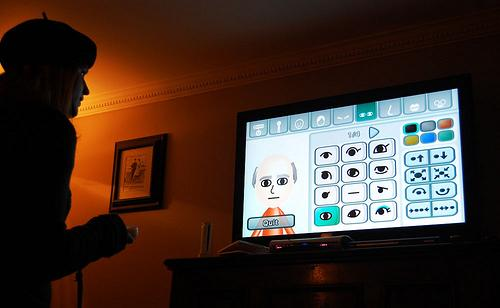Why are there eyes on the screen? Please explain your reasoning. customizing avatar. They are creating a character they want to see in a game 